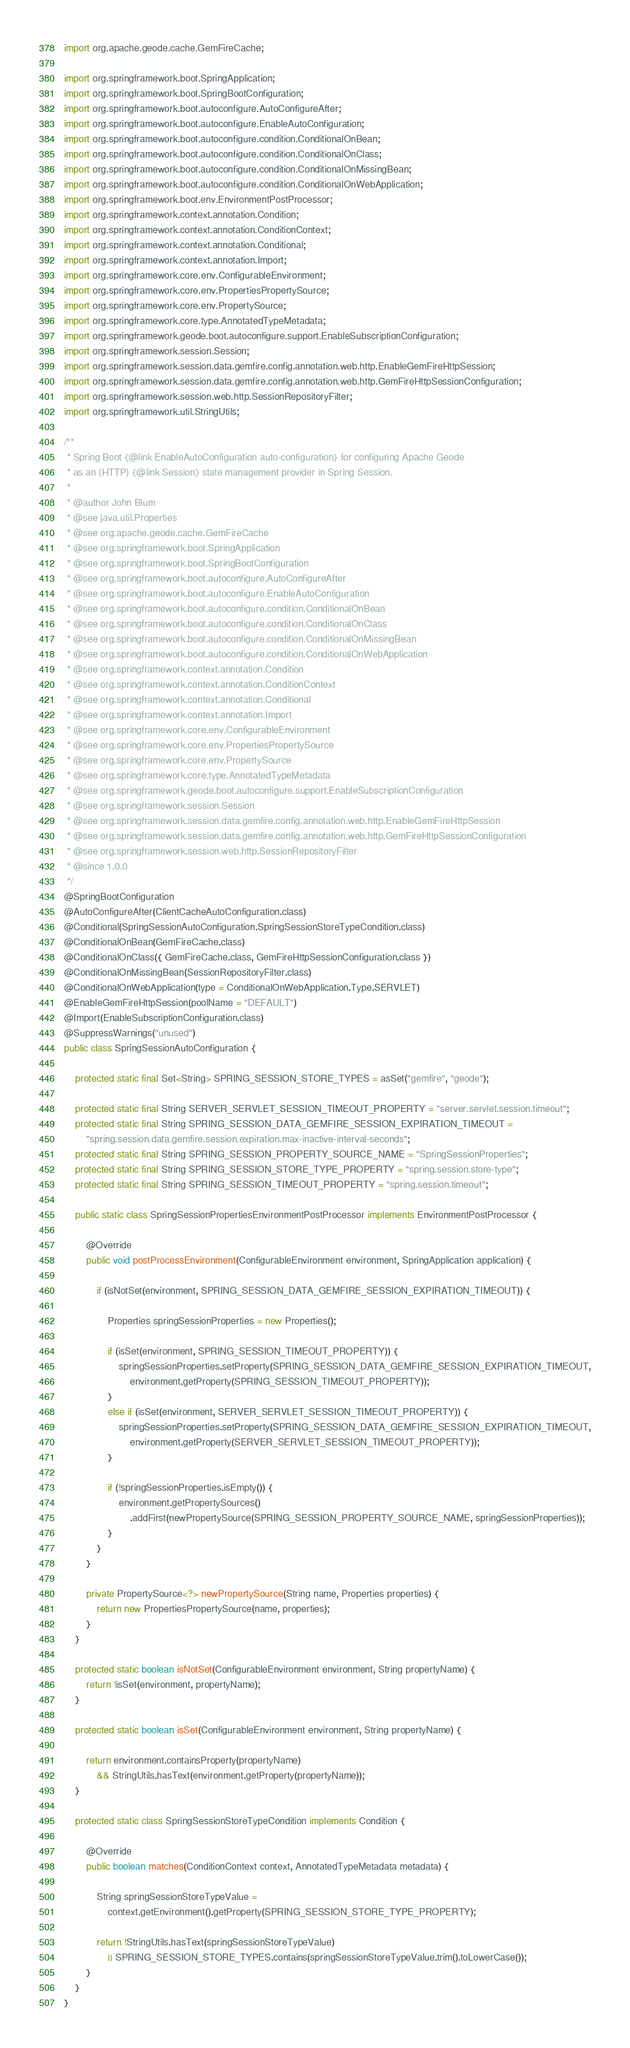<code> <loc_0><loc_0><loc_500><loc_500><_Java_>import org.apache.geode.cache.GemFireCache;

import org.springframework.boot.SpringApplication;
import org.springframework.boot.SpringBootConfiguration;
import org.springframework.boot.autoconfigure.AutoConfigureAfter;
import org.springframework.boot.autoconfigure.EnableAutoConfiguration;
import org.springframework.boot.autoconfigure.condition.ConditionalOnBean;
import org.springframework.boot.autoconfigure.condition.ConditionalOnClass;
import org.springframework.boot.autoconfigure.condition.ConditionalOnMissingBean;
import org.springframework.boot.autoconfigure.condition.ConditionalOnWebApplication;
import org.springframework.boot.env.EnvironmentPostProcessor;
import org.springframework.context.annotation.Condition;
import org.springframework.context.annotation.ConditionContext;
import org.springframework.context.annotation.Conditional;
import org.springframework.context.annotation.Import;
import org.springframework.core.env.ConfigurableEnvironment;
import org.springframework.core.env.PropertiesPropertySource;
import org.springframework.core.env.PropertySource;
import org.springframework.core.type.AnnotatedTypeMetadata;
import org.springframework.geode.boot.autoconfigure.support.EnableSubscriptionConfiguration;
import org.springframework.session.Session;
import org.springframework.session.data.gemfire.config.annotation.web.http.EnableGemFireHttpSession;
import org.springframework.session.data.gemfire.config.annotation.web.http.GemFireHttpSessionConfiguration;
import org.springframework.session.web.http.SessionRepositoryFilter;
import org.springframework.util.StringUtils;

/**
 * Spring Boot {@link EnableAutoConfiguration auto-configuration} for configuring Apache Geode
 * as an (HTTP) {@link Session} state management provider in Spring Session.
 *
 * @author John Blum
 * @see java.util.Properties
 * @see org.apache.geode.cache.GemFireCache
 * @see org.springframework.boot.SpringApplication
 * @see org.springframework.boot.SpringBootConfiguration
 * @see org.springframework.boot.autoconfigure.AutoConfigureAfter
 * @see org.springframework.boot.autoconfigure.EnableAutoConfiguration
 * @see org.springframework.boot.autoconfigure.condition.ConditionalOnBean
 * @see org.springframework.boot.autoconfigure.condition.ConditionalOnClass
 * @see org.springframework.boot.autoconfigure.condition.ConditionalOnMissingBean
 * @see org.springframework.boot.autoconfigure.condition.ConditionalOnWebApplication
 * @see org.springframework.context.annotation.Condition
 * @see org.springframework.context.annotation.ConditionContext
 * @see org.springframework.context.annotation.Conditional
 * @see org.springframework.context.annotation.Import
 * @see org.springframework.core.env.ConfigurableEnvironment
 * @see org.springframework.core.env.PropertiesPropertySource
 * @see org.springframework.core.env.PropertySource
 * @see org.springframework.core.type.AnnotatedTypeMetadata
 * @see org.springframework.geode.boot.autoconfigure.support.EnableSubscriptionConfiguration
 * @see org.springframework.session.Session
 * @see org.springframework.session.data.gemfire.config.annotation.web.http.EnableGemFireHttpSession
 * @see org.springframework.session.data.gemfire.config.annotation.web.http.GemFireHttpSessionConfiguration
 * @see org.springframework.session.web.http.SessionRepositoryFilter
 * @since 1.0.0
 */
@SpringBootConfiguration
@AutoConfigureAfter(ClientCacheAutoConfiguration.class)
@Conditional(SpringSessionAutoConfiguration.SpringSessionStoreTypeCondition.class)
@ConditionalOnBean(GemFireCache.class)
@ConditionalOnClass({ GemFireCache.class, GemFireHttpSessionConfiguration.class })
@ConditionalOnMissingBean(SessionRepositoryFilter.class)
@ConditionalOnWebApplication(type = ConditionalOnWebApplication.Type.SERVLET)
@EnableGemFireHttpSession(poolName = "DEFAULT")
@Import(EnableSubscriptionConfiguration.class)
@SuppressWarnings("unused")
public class SpringSessionAutoConfiguration {

	protected static final Set<String> SPRING_SESSION_STORE_TYPES = asSet("gemfire", "geode");

	protected static final String SERVER_SERVLET_SESSION_TIMEOUT_PROPERTY = "server.servlet.session.timeout";
	protected static final String SPRING_SESSION_DATA_GEMFIRE_SESSION_EXPIRATION_TIMEOUT =
		"spring.session.data.gemfire.session.expiration.max-inactive-interval-seconds";
	protected static final String SPRING_SESSION_PROPERTY_SOURCE_NAME = "SpringSessionProperties";
	protected static final String SPRING_SESSION_STORE_TYPE_PROPERTY = "spring.session.store-type";
	protected static final String SPRING_SESSION_TIMEOUT_PROPERTY = "spring.session.timeout";

	public static class SpringSessionPropertiesEnvironmentPostProcessor implements EnvironmentPostProcessor {

		@Override
		public void postProcessEnvironment(ConfigurableEnvironment environment, SpringApplication application) {

			if (isNotSet(environment, SPRING_SESSION_DATA_GEMFIRE_SESSION_EXPIRATION_TIMEOUT)) {

				Properties springSessionProperties = new Properties();

				if (isSet(environment, SPRING_SESSION_TIMEOUT_PROPERTY)) {
					springSessionProperties.setProperty(SPRING_SESSION_DATA_GEMFIRE_SESSION_EXPIRATION_TIMEOUT,
						environment.getProperty(SPRING_SESSION_TIMEOUT_PROPERTY));
				}
				else if (isSet(environment, SERVER_SERVLET_SESSION_TIMEOUT_PROPERTY)) {
					springSessionProperties.setProperty(SPRING_SESSION_DATA_GEMFIRE_SESSION_EXPIRATION_TIMEOUT,
						environment.getProperty(SERVER_SERVLET_SESSION_TIMEOUT_PROPERTY));
				}

				if (!springSessionProperties.isEmpty()) {
					environment.getPropertySources()
						.addFirst(newPropertySource(SPRING_SESSION_PROPERTY_SOURCE_NAME, springSessionProperties));
				}
			}
		}

		private PropertySource<?> newPropertySource(String name, Properties properties) {
			return new PropertiesPropertySource(name, properties);
		}
	}

	protected static boolean isNotSet(ConfigurableEnvironment environment, String propertyName) {
		return !isSet(environment, propertyName);
	}

	protected static boolean isSet(ConfigurableEnvironment environment, String propertyName) {

		return environment.containsProperty(propertyName)
			&& StringUtils.hasText(environment.getProperty(propertyName));
	}

	protected static class SpringSessionStoreTypeCondition implements Condition {

		@Override
		public boolean matches(ConditionContext context, AnnotatedTypeMetadata metadata) {

			String springSessionStoreTypeValue =
				context.getEnvironment().getProperty(SPRING_SESSION_STORE_TYPE_PROPERTY);

			return !StringUtils.hasText(springSessionStoreTypeValue)
				|| SPRING_SESSION_STORE_TYPES.contains(springSessionStoreTypeValue.trim().toLowerCase());
		}
	}
}
</code> 